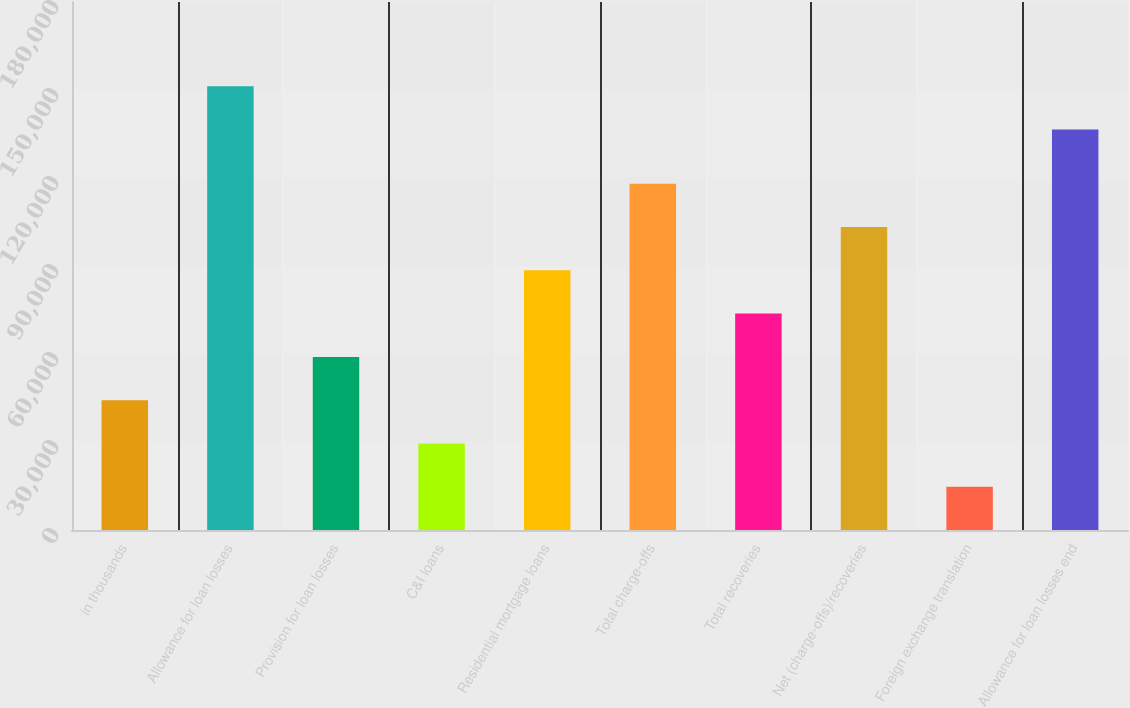<chart> <loc_0><loc_0><loc_500><loc_500><bar_chart><fcel>in thousands<fcel>Allowance for loan losses<fcel>Provision for loan losses<fcel>C&I loans<fcel>Residential mortgage loans<fcel>Total charge-offs<fcel>Total recoveries<fcel>Net (charge-offs)/recoveries<fcel>Foreign exchange translation<fcel>Allowance for loan losses end<nl><fcel>44263.4<fcel>151255<fcel>59017.3<fcel>29509.4<fcel>88525.2<fcel>118033<fcel>73771.3<fcel>103279<fcel>14755.5<fcel>136501<nl></chart> 